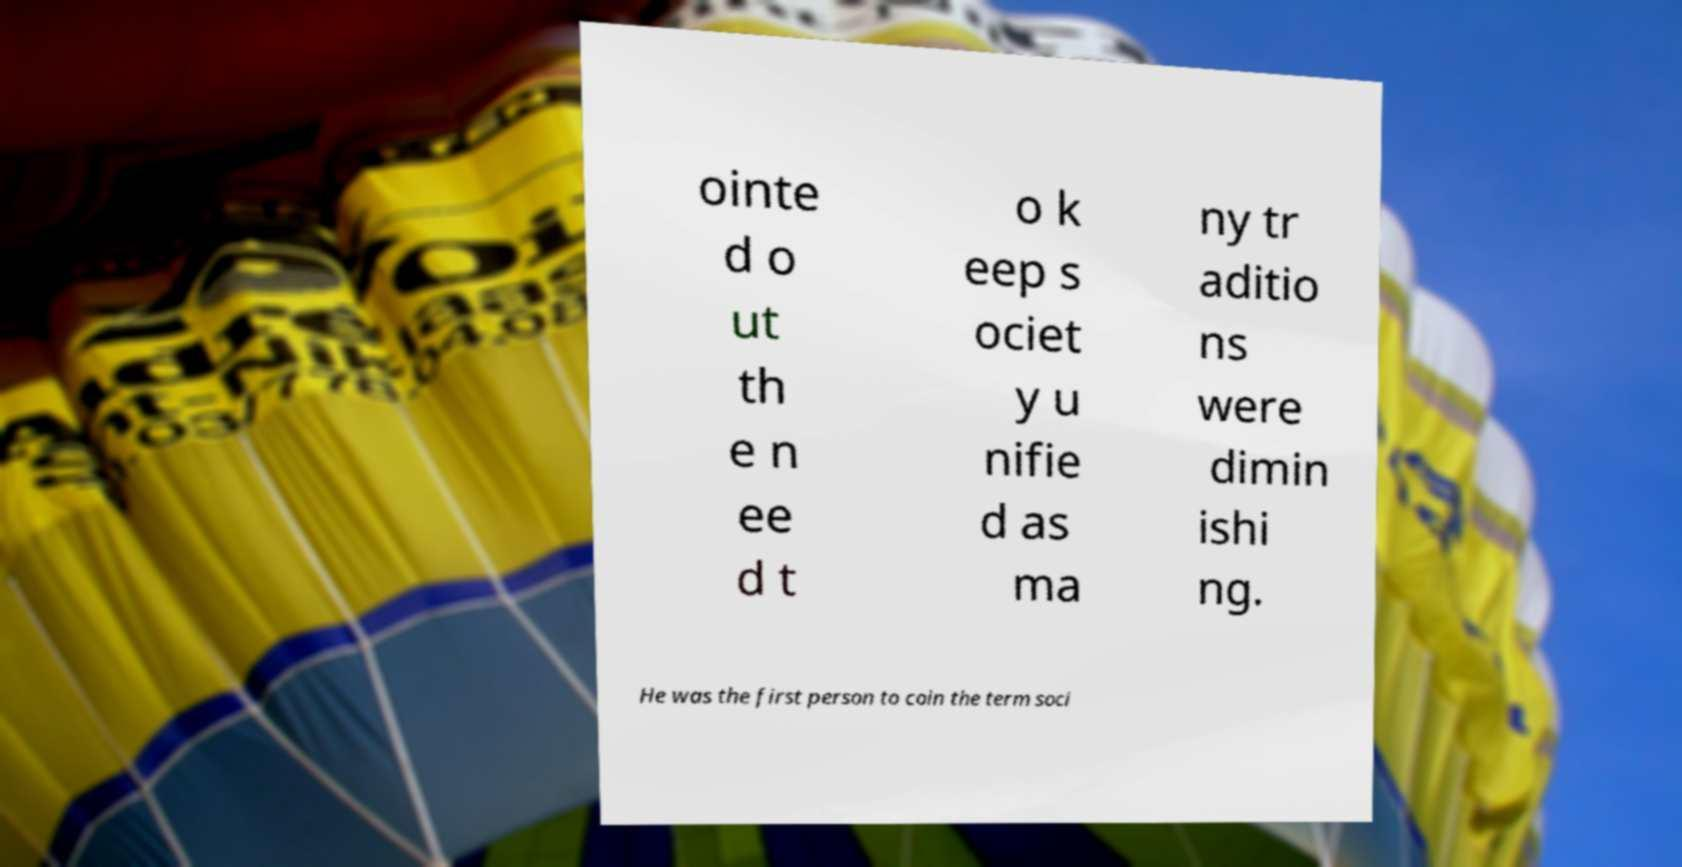Can you accurately transcribe the text from the provided image for me? ointe d o ut th e n ee d t o k eep s ociet y u nifie d as ma ny tr aditio ns were dimin ishi ng. He was the first person to coin the term soci 